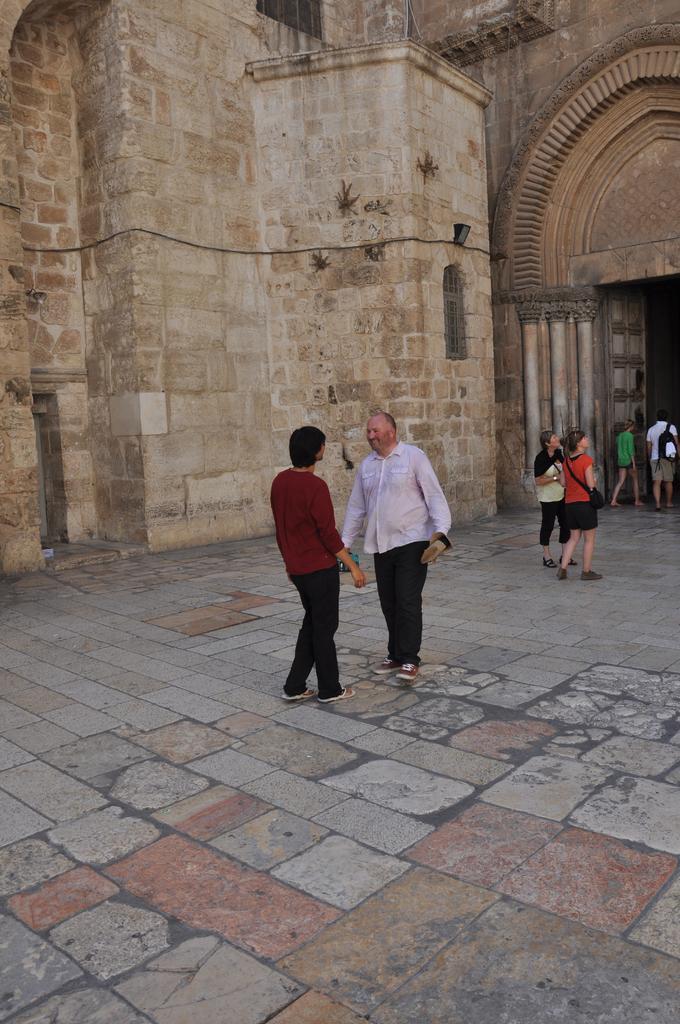In one or two sentences, can you explain what this image depicts? In this image I can see group of people, some are walking and some are standing. In front the person is wearing white shirt and black pant. The person at left is wearing maroon shirt and black pant, background the wall is in cream and brown color. 